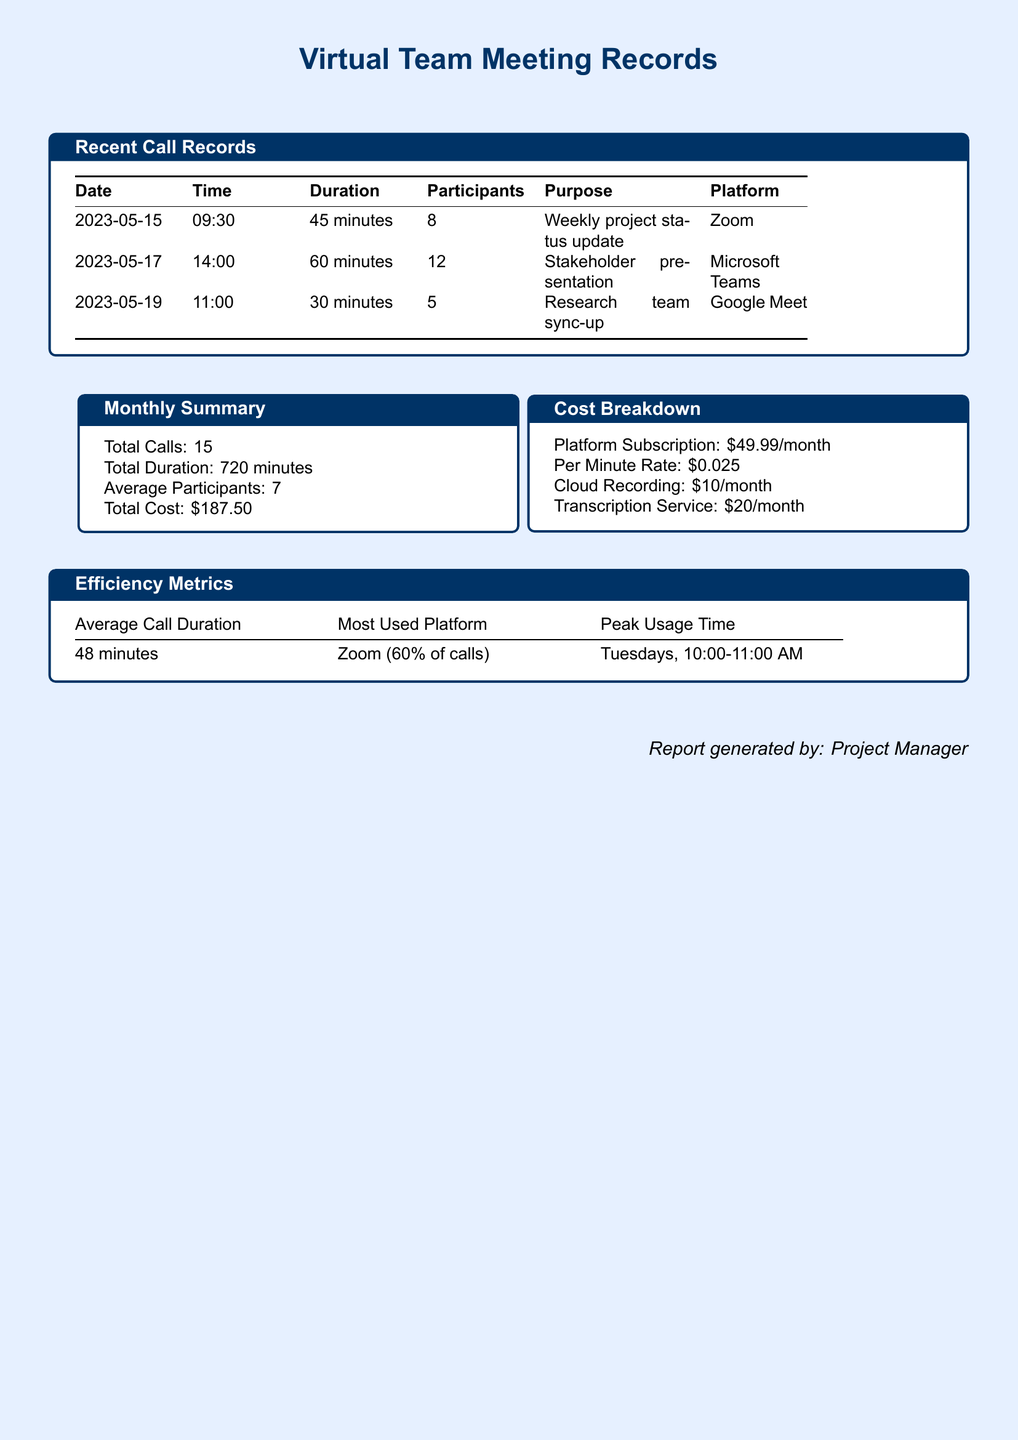What is the total number of calls? The total number of calls is stated in the monthly summary section of the document.
Answer: 15 What platform had the peak usage? The most used platform is identified in the efficiency metrics section of the document.
Answer: Zoom What was the duration of the stakeholder presentation? The duration for the stakeholder presentation is indicated in the recent call records table.
Answer: 60 minutes What is the cost of the transcription service? The cost breakdown section of the document specifies the transcription service cost.
Answer: $20/month On which day did the most calls occur? Reasoning over the average call duration suggests Tuesday is the peak usage day as indicated by the metrics.
Answer: Tuesday What is the total duration of calls in minutes? The total duration is provided in the monthly summary section of the document.
Answer: 720 minutes What is the average number of participants in the calls? The average participants is mentioned in the monthly summary section.
Answer: 7 What date was the weekly project status update? The specific date can be found in the recent call records table in the document.
Answer: 2023-05-15 What is the per minute rate for calls? The cost breakdown section lists this rate directly.
Answer: $0.025 